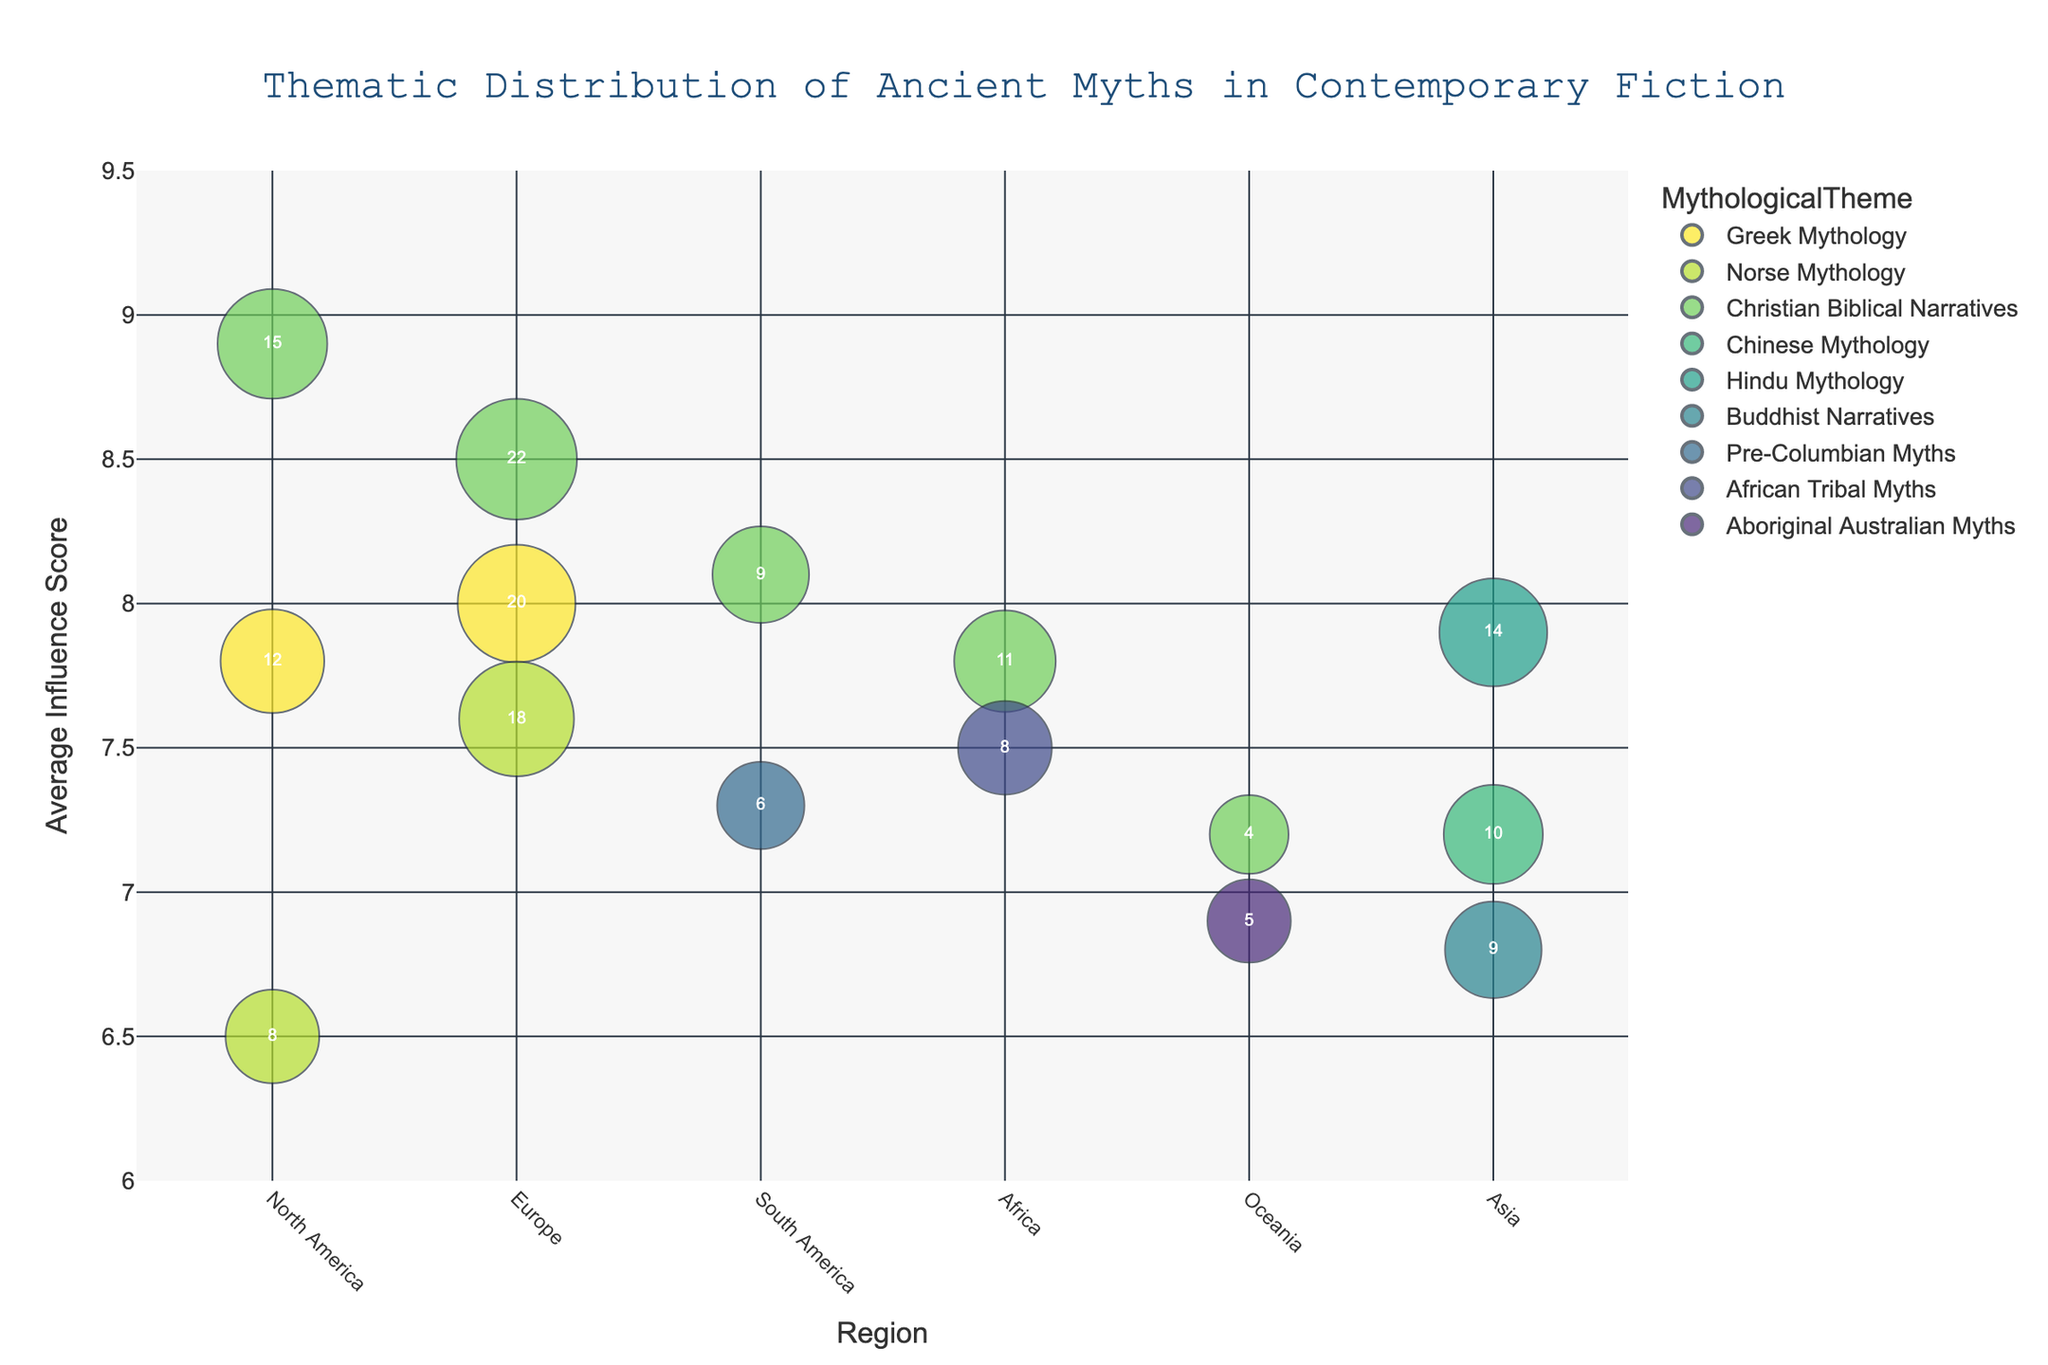what is the title of the chart? The title is located at the top center of the chart and typically is larger in font size and distinct in color.
Answer: Thematic Distribution of Ancient Myths in Contemporary Fiction How many regions are represented in the chart? By observing the x-axis, count the distinct region names listed.
Answer: 6 Which mythological theme has the highest average influence score in North America? Identify the bubbles on the chart corresponding to North America by looking at the x-axis, then find the bubble with the highest y-axis position.
Answer: Christian Biblical Narratives What is the total number of books influenced by Christian Biblical Narratives in all regions? Locate all the bubbles associated with Christian Biblical Narratives, then sum their respective NumberOfBooks values by looking at the numbers in the centers of these bubbles.
Answer: 61 Which region has the least representation of mythological themes based on the number of bubbles? Count the number of bubbles present for each region and identify the one with the fewest bubbles.
Answer: Oceania What is the average influence score of Greek Mythology across all regions? Identify the bubbles linked to Greek Mythology, note their respective y-axis values (Average Influence Score), and calculate the arithmetic mean of these values.
Answer: 7.9 Compare the representation of Norse Mythology in Europe and North America. Which has a higher average influence score and by how much? Identify the bubbles corresponding to Norse Mythology in both regions, then subtract the influence score of North America from that of Europe.
Answer: Europe has a 1.1 higher average influence score In which region does Pre-Columbian Myths appear and what is its average influence score? Look for the bubble labeled Pre-Columbian Myths and note its corresponding region on the x-axis and the position on the y-axis.
Answer: South America, 7.3 Across all mythological themes, which one has the highest average influence score in any region? Observe the y-axis values for all bubbles and identify the highest position. Then, find the corresponding mythological theme.
Answer: Christian Biblical Narratives in North America What is the difference in the number of books between African Tribal Myths and Aboriginal Australian Myths? Note the numbers in the centers of the bubbles corresponding to these mythological themes, then subtract the smaller number from the larger one.
Answer: 3 